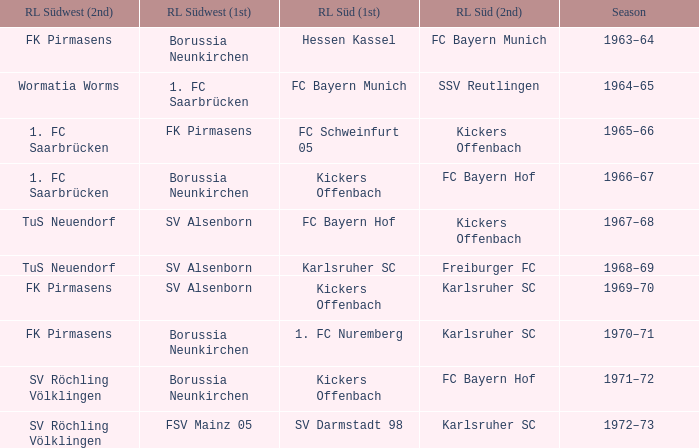Who was RL Süd (1st) when FK Pirmasens was RL Südwest (1st)? FC Schweinfurt 05. 